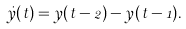<formula> <loc_0><loc_0><loc_500><loc_500>\dot { y } ( t ) = y ( t - 2 ) - y ( t - 1 ) .</formula> 